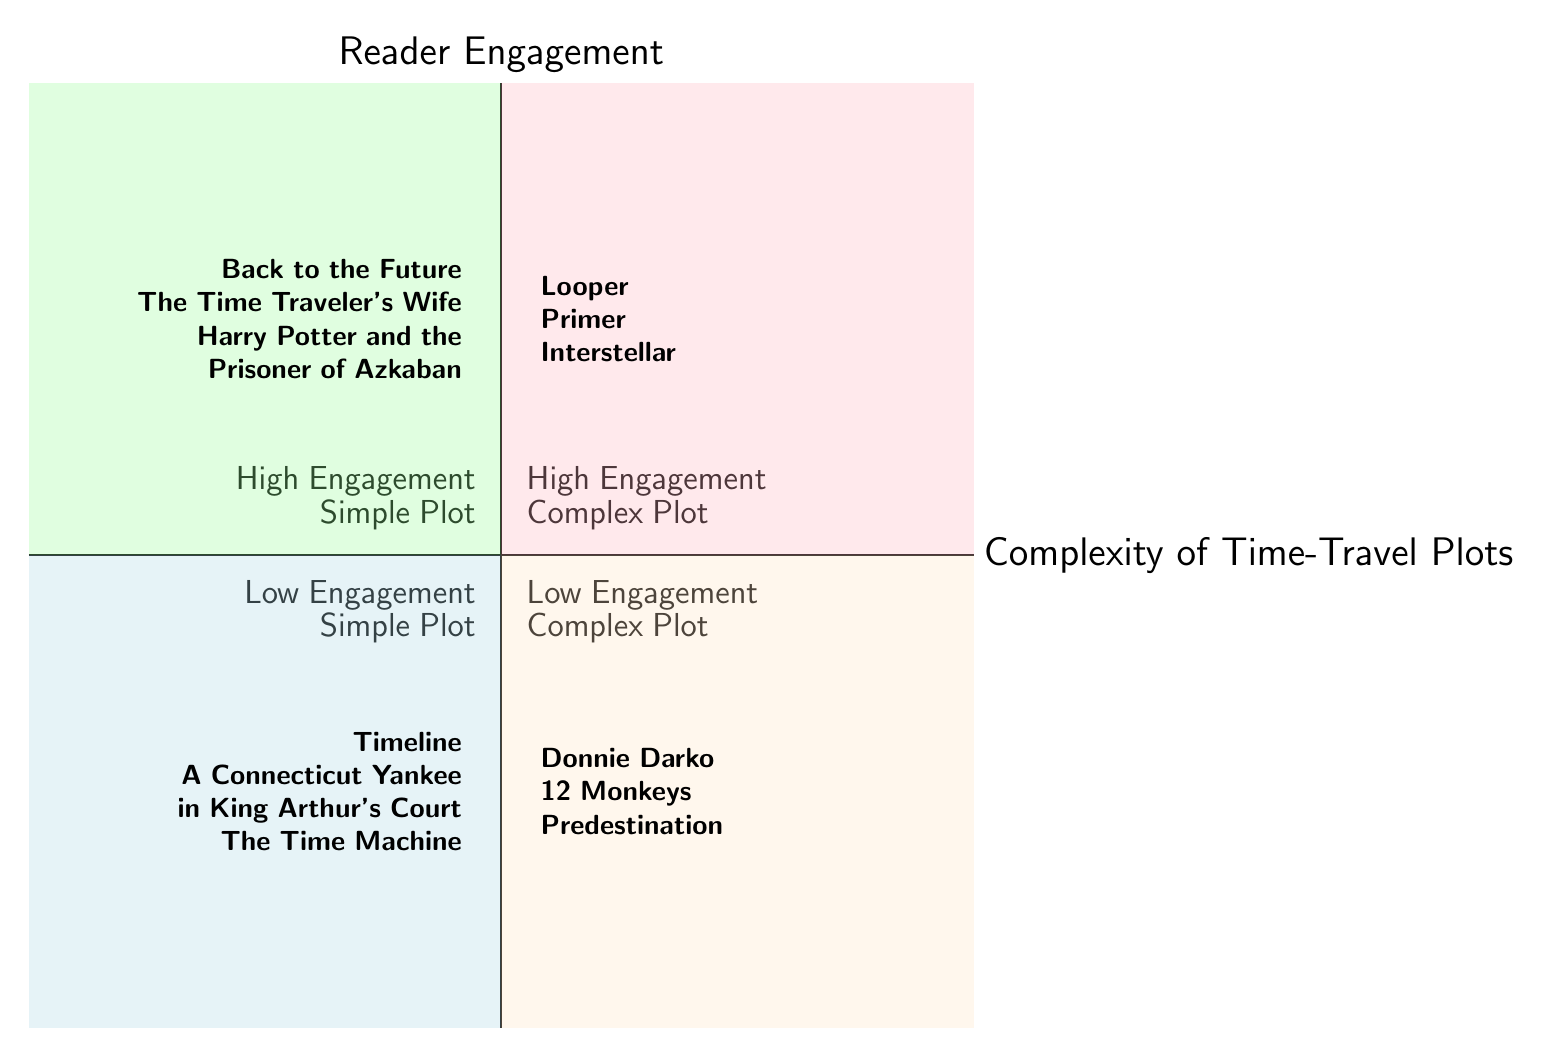What are some examples of works in the "High Engagement - Simple Plot" quadrant? The diagram lists three specific works in the "High Engagement - Simple Plot" quadrant: "Back to the Future," "The Time Traveler's Wife," and "Harry Potter and the Prisoner of Azkaban."
Answer: Back to the Future, The Time Traveler's Wife, Harry Potter and the Prisoner of Azkaban How many works are in the "Low Engagement - Complex Plot" quadrant? According to the diagram, there are three works listed in the "Low Engagement - Complex Plot" quadrant: "Donnie Darko," "12 Monkeys," and "Predestination." Therefore, the count is three.
Answer: 3 Which quadrant contains "Looper"? "Looper" is mentioned in the "High Engagement - Complex Plot" quadrant of the diagram, indicating its categorization in terms of reader engagement and plot complexity.
Answer: High Engagement - Complex Plot What is the relationship between "Timeline" and "A Connecticut Yankee in King Arthur's Court"? Both "Timeline" and "A Connecticut Yankee in King Arthur's Court" are located in the "Low Engagement - Simple Plot" quadrant, indicating they share a similar level of reader engagement and plot simplicity.
Answer: Same quadrant (Low Engagement - Simple Plot) Which quadrant has the highest engagement level? The "High Engagement - Complex Plot" quadrant has the highest engagement level, as per the categorization of plots and their respective reader engagement levels in the diagram.
Answer: High Engagement - Complex Plot List one title from the "Low Engagement - Simple Plot" quadrant. The title "Timeline" is one of the works listed in the "Low Engagement - Simple Plot" quadrant, as can be seen in the diagram.
Answer: Timeline How do the complexities of plots in the "High Engagement" quadrants compare to those in the "Low Engagement" quadrants? The "High Engagement" quadrants contain works with either simple plots (e.g., "Back to the Future") or complex plots (e.g., "Looper"), while the "Low Engagement" quadrants contain works with simple plots (e.g., "Timeline") and complex plots (e.g., "Donnie Darko"). This analysis indicates that higher engagement tends to occur in both simple and complex narratives.
Answer: Higher engagement in both simple and complex plots Which title is in the "Low Engagement - Complex Plot" quadrant? The diagram specifies three titles in the "Low Engagement - Complex Plot" quadrant: "Donnie Darko," "12 Monkeys," and "Predestination." Selecting any of these titles answers the question accurately.
Answer: Donnie Darko (or 12 Monkeys, or Predestination) 